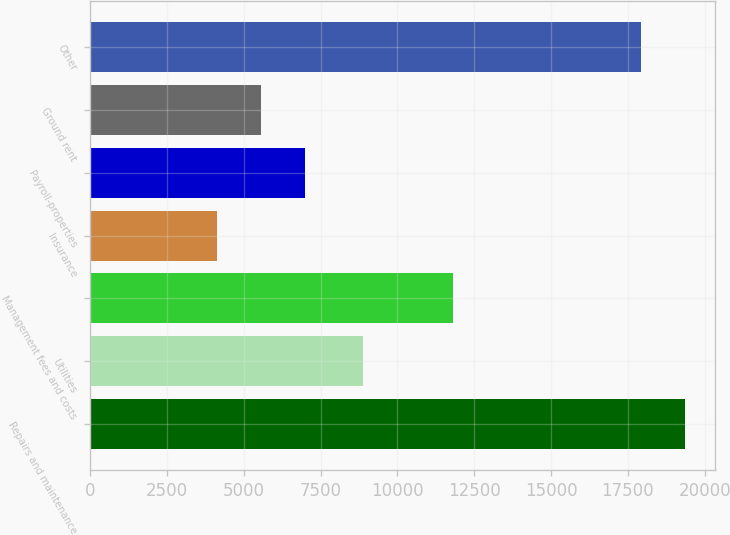<chart> <loc_0><loc_0><loc_500><loc_500><bar_chart><fcel>Repairs and maintenance<fcel>Utilities<fcel>Management fees and costs<fcel>Insurance<fcel>Payroll-properties<fcel>Ground rent<fcel>Other<nl><fcel>19365.6<fcel>8868<fcel>11823<fcel>4144<fcel>6991.2<fcel>5567.6<fcel>17942<nl></chart> 